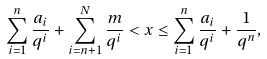Convert formula to latex. <formula><loc_0><loc_0><loc_500><loc_500>\sum _ { i = 1 } ^ { n } \frac { a _ { i } } { q ^ { i } } + \sum _ { i = n + 1 } ^ { N } \frac { m } { q ^ { i } } < x \leq \sum _ { i = 1 } ^ { n } \frac { a _ { i } } { q ^ { i } } + \frac { 1 } { q ^ { n } } ,</formula> 